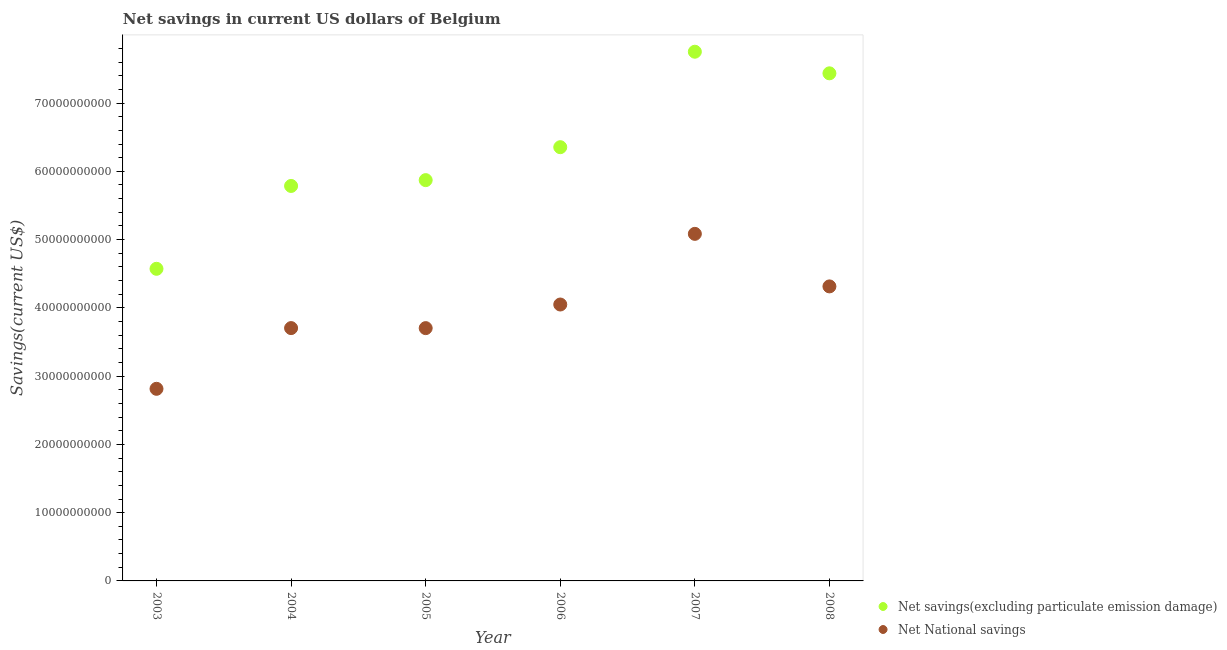What is the net savings(excluding particulate emission damage) in 2007?
Ensure brevity in your answer.  7.75e+1. Across all years, what is the maximum net national savings?
Your answer should be very brief. 5.08e+1. Across all years, what is the minimum net national savings?
Give a very brief answer. 2.81e+1. What is the total net national savings in the graph?
Give a very brief answer. 2.37e+11. What is the difference between the net national savings in 2003 and that in 2008?
Offer a terse response. -1.50e+1. What is the difference between the net savings(excluding particulate emission damage) in 2007 and the net national savings in 2005?
Offer a very short reply. 4.05e+1. What is the average net savings(excluding particulate emission damage) per year?
Provide a succinct answer. 6.30e+1. In the year 2007, what is the difference between the net national savings and net savings(excluding particulate emission damage)?
Ensure brevity in your answer.  -2.67e+1. What is the ratio of the net savings(excluding particulate emission damage) in 2004 to that in 2008?
Offer a terse response. 0.78. Is the net national savings in 2004 less than that in 2008?
Your answer should be compact. Yes. What is the difference between the highest and the second highest net savings(excluding particulate emission damage)?
Your answer should be very brief. 3.16e+09. What is the difference between the highest and the lowest net savings(excluding particulate emission damage)?
Offer a very short reply. 3.18e+1. Does the net national savings monotonically increase over the years?
Offer a terse response. No. Is the net national savings strictly less than the net savings(excluding particulate emission damage) over the years?
Your response must be concise. Yes. How many years are there in the graph?
Provide a short and direct response. 6. What is the difference between two consecutive major ticks on the Y-axis?
Give a very brief answer. 1.00e+1. Are the values on the major ticks of Y-axis written in scientific E-notation?
Provide a short and direct response. No. Does the graph contain any zero values?
Ensure brevity in your answer.  No. Where does the legend appear in the graph?
Offer a very short reply. Bottom right. How many legend labels are there?
Offer a terse response. 2. How are the legend labels stacked?
Provide a short and direct response. Vertical. What is the title of the graph?
Offer a very short reply. Net savings in current US dollars of Belgium. Does "Netherlands" appear as one of the legend labels in the graph?
Provide a succinct answer. No. What is the label or title of the Y-axis?
Your answer should be very brief. Savings(current US$). What is the Savings(current US$) of Net savings(excluding particulate emission damage) in 2003?
Ensure brevity in your answer.  4.57e+1. What is the Savings(current US$) of Net National savings in 2003?
Provide a short and direct response. 2.81e+1. What is the Savings(current US$) of Net savings(excluding particulate emission damage) in 2004?
Ensure brevity in your answer.  5.79e+1. What is the Savings(current US$) in Net National savings in 2004?
Give a very brief answer. 3.70e+1. What is the Savings(current US$) in Net savings(excluding particulate emission damage) in 2005?
Offer a very short reply. 5.87e+1. What is the Savings(current US$) in Net National savings in 2005?
Offer a very short reply. 3.70e+1. What is the Savings(current US$) in Net savings(excluding particulate emission damage) in 2006?
Give a very brief answer. 6.35e+1. What is the Savings(current US$) of Net National savings in 2006?
Your response must be concise. 4.05e+1. What is the Savings(current US$) in Net savings(excluding particulate emission damage) in 2007?
Your answer should be compact. 7.75e+1. What is the Savings(current US$) of Net National savings in 2007?
Provide a succinct answer. 5.08e+1. What is the Savings(current US$) of Net savings(excluding particulate emission damage) in 2008?
Your answer should be compact. 7.44e+1. What is the Savings(current US$) in Net National savings in 2008?
Your answer should be compact. 4.31e+1. Across all years, what is the maximum Savings(current US$) in Net savings(excluding particulate emission damage)?
Keep it short and to the point. 7.75e+1. Across all years, what is the maximum Savings(current US$) in Net National savings?
Provide a short and direct response. 5.08e+1. Across all years, what is the minimum Savings(current US$) in Net savings(excluding particulate emission damage)?
Offer a terse response. 4.57e+1. Across all years, what is the minimum Savings(current US$) of Net National savings?
Make the answer very short. 2.81e+1. What is the total Savings(current US$) in Net savings(excluding particulate emission damage) in the graph?
Your answer should be compact. 3.78e+11. What is the total Savings(current US$) in Net National savings in the graph?
Keep it short and to the point. 2.37e+11. What is the difference between the Savings(current US$) in Net savings(excluding particulate emission damage) in 2003 and that in 2004?
Offer a terse response. -1.21e+1. What is the difference between the Savings(current US$) of Net National savings in 2003 and that in 2004?
Ensure brevity in your answer.  -8.90e+09. What is the difference between the Savings(current US$) in Net savings(excluding particulate emission damage) in 2003 and that in 2005?
Your response must be concise. -1.30e+1. What is the difference between the Savings(current US$) of Net National savings in 2003 and that in 2005?
Keep it short and to the point. -8.89e+09. What is the difference between the Savings(current US$) of Net savings(excluding particulate emission damage) in 2003 and that in 2006?
Ensure brevity in your answer.  -1.78e+1. What is the difference between the Savings(current US$) of Net National savings in 2003 and that in 2006?
Provide a short and direct response. -1.23e+1. What is the difference between the Savings(current US$) of Net savings(excluding particulate emission damage) in 2003 and that in 2007?
Your answer should be compact. -3.18e+1. What is the difference between the Savings(current US$) in Net National savings in 2003 and that in 2007?
Make the answer very short. -2.27e+1. What is the difference between the Savings(current US$) in Net savings(excluding particulate emission damage) in 2003 and that in 2008?
Your answer should be compact. -2.86e+1. What is the difference between the Savings(current US$) of Net National savings in 2003 and that in 2008?
Your response must be concise. -1.50e+1. What is the difference between the Savings(current US$) of Net savings(excluding particulate emission damage) in 2004 and that in 2005?
Your answer should be compact. -8.53e+08. What is the difference between the Savings(current US$) of Net National savings in 2004 and that in 2005?
Your response must be concise. 5.81e+06. What is the difference between the Savings(current US$) of Net savings(excluding particulate emission damage) in 2004 and that in 2006?
Keep it short and to the point. -5.68e+09. What is the difference between the Savings(current US$) in Net National savings in 2004 and that in 2006?
Your response must be concise. -3.45e+09. What is the difference between the Savings(current US$) in Net savings(excluding particulate emission damage) in 2004 and that in 2007?
Offer a very short reply. -1.97e+1. What is the difference between the Savings(current US$) in Net National savings in 2004 and that in 2007?
Provide a succinct answer. -1.38e+1. What is the difference between the Savings(current US$) in Net savings(excluding particulate emission damage) in 2004 and that in 2008?
Offer a very short reply. -1.65e+1. What is the difference between the Savings(current US$) of Net National savings in 2004 and that in 2008?
Give a very brief answer. -6.11e+09. What is the difference between the Savings(current US$) of Net savings(excluding particulate emission damage) in 2005 and that in 2006?
Make the answer very short. -4.83e+09. What is the difference between the Savings(current US$) of Net National savings in 2005 and that in 2006?
Provide a succinct answer. -3.46e+09. What is the difference between the Savings(current US$) in Net savings(excluding particulate emission damage) in 2005 and that in 2007?
Keep it short and to the point. -1.88e+1. What is the difference between the Savings(current US$) of Net National savings in 2005 and that in 2007?
Offer a terse response. -1.38e+1. What is the difference between the Savings(current US$) in Net savings(excluding particulate emission damage) in 2005 and that in 2008?
Provide a short and direct response. -1.56e+1. What is the difference between the Savings(current US$) of Net National savings in 2005 and that in 2008?
Your response must be concise. -6.11e+09. What is the difference between the Savings(current US$) of Net savings(excluding particulate emission damage) in 2006 and that in 2007?
Provide a short and direct response. -1.40e+1. What is the difference between the Savings(current US$) of Net National savings in 2006 and that in 2007?
Provide a short and direct response. -1.04e+1. What is the difference between the Savings(current US$) in Net savings(excluding particulate emission damage) in 2006 and that in 2008?
Provide a succinct answer. -1.08e+1. What is the difference between the Savings(current US$) in Net National savings in 2006 and that in 2008?
Provide a succinct answer. -2.65e+09. What is the difference between the Savings(current US$) in Net savings(excluding particulate emission damage) in 2007 and that in 2008?
Your answer should be compact. 3.16e+09. What is the difference between the Savings(current US$) in Net National savings in 2007 and that in 2008?
Make the answer very short. 7.70e+09. What is the difference between the Savings(current US$) of Net savings(excluding particulate emission damage) in 2003 and the Savings(current US$) of Net National savings in 2004?
Your response must be concise. 8.69e+09. What is the difference between the Savings(current US$) in Net savings(excluding particulate emission damage) in 2003 and the Savings(current US$) in Net National savings in 2005?
Offer a terse response. 8.69e+09. What is the difference between the Savings(current US$) in Net savings(excluding particulate emission damage) in 2003 and the Savings(current US$) in Net National savings in 2006?
Give a very brief answer. 5.23e+09. What is the difference between the Savings(current US$) in Net savings(excluding particulate emission damage) in 2003 and the Savings(current US$) in Net National savings in 2007?
Provide a short and direct response. -5.12e+09. What is the difference between the Savings(current US$) of Net savings(excluding particulate emission damage) in 2003 and the Savings(current US$) of Net National savings in 2008?
Your answer should be compact. 2.58e+09. What is the difference between the Savings(current US$) in Net savings(excluding particulate emission damage) in 2004 and the Savings(current US$) in Net National savings in 2005?
Provide a short and direct response. 2.08e+1. What is the difference between the Savings(current US$) of Net savings(excluding particulate emission damage) in 2004 and the Savings(current US$) of Net National savings in 2006?
Provide a short and direct response. 1.74e+1. What is the difference between the Savings(current US$) in Net savings(excluding particulate emission damage) in 2004 and the Savings(current US$) in Net National savings in 2007?
Your answer should be very brief. 7.02e+09. What is the difference between the Savings(current US$) in Net savings(excluding particulate emission damage) in 2004 and the Savings(current US$) in Net National savings in 2008?
Ensure brevity in your answer.  1.47e+1. What is the difference between the Savings(current US$) in Net savings(excluding particulate emission damage) in 2005 and the Savings(current US$) in Net National savings in 2006?
Ensure brevity in your answer.  1.82e+1. What is the difference between the Savings(current US$) of Net savings(excluding particulate emission damage) in 2005 and the Savings(current US$) of Net National savings in 2007?
Your answer should be very brief. 7.87e+09. What is the difference between the Savings(current US$) of Net savings(excluding particulate emission damage) in 2005 and the Savings(current US$) of Net National savings in 2008?
Make the answer very short. 1.56e+1. What is the difference between the Savings(current US$) in Net savings(excluding particulate emission damage) in 2006 and the Savings(current US$) in Net National savings in 2007?
Ensure brevity in your answer.  1.27e+1. What is the difference between the Savings(current US$) of Net savings(excluding particulate emission damage) in 2006 and the Savings(current US$) of Net National savings in 2008?
Your answer should be very brief. 2.04e+1. What is the difference between the Savings(current US$) of Net savings(excluding particulate emission damage) in 2007 and the Savings(current US$) of Net National savings in 2008?
Your answer should be very brief. 3.44e+1. What is the average Savings(current US$) in Net savings(excluding particulate emission damage) per year?
Ensure brevity in your answer.  6.30e+1. What is the average Savings(current US$) of Net National savings per year?
Your response must be concise. 3.94e+1. In the year 2003, what is the difference between the Savings(current US$) in Net savings(excluding particulate emission damage) and Savings(current US$) in Net National savings?
Provide a short and direct response. 1.76e+1. In the year 2004, what is the difference between the Savings(current US$) of Net savings(excluding particulate emission damage) and Savings(current US$) of Net National savings?
Provide a succinct answer. 2.08e+1. In the year 2005, what is the difference between the Savings(current US$) in Net savings(excluding particulate emission damage) and Savings(current US$) in Net National savings?
Give a very brief answer. 2.17e+1. In the year 2006, what is the difference between the Savings(current US$) in Net savings(excluding particulate emission damage) and Savings(current US$) in Net National savings?
Your answer should be compact. 2.30e+1. In the year 2007, what is the difference between the Savings(current US$) of Net savings(excluding particulate emission damage) and Savings(current US$) of Net National savings?
Keep it short and to the point. 2.67e+1. In the year 2008, what is the difference between the Savings(current US$) in Net savings(excluding particulate emission damage) and Savings(current US$) in Net National savings?
Make the answer very short. 3.12e+1. What is the ratio of the Savings(current US$) in Net savings(excluding particulate emission damage) in 2003 to that in 2004?
Provide a short and direct response. 0.79. What is the ratio of the Savings(current US$) of Net National savings in 2003 to that in 2004?
Offer a terse response. 0.76. What is the ratio of the Savings(current US$) in Net savings(excluding particulate emission damage) in 2003 to that in 2005?
Offer a terse response. 0.78. What is the ratio of the Savings(current US$) in Net National savings in 2003 to that in 2005?
Ensure brevity in your answer.  0.76. What is the ratio of the Savings(current US$) of Net savings(excluding particulate emission damage) in 2003 to that in 2006?
Offer a terse response. 0.72. What is the ratio of the Savings(current US$) of Net National savings in 2003 to that in 2006?
Make the answer very short. 0.69. What is the ratio of the Savings(current US$) in Net savings(excluding particulate emission damage) in 2003 to that in 2007?
Offer a terse response. 0.59. What is the ratio of the Savings(current US$) in Net National savings in 2003 to that in 2007?
Your response must be concise. 0.55. What is the ratio of the Savings(current US$) of Net savings(excluding particulate emission damage) in 2003 to that in 2008?
Provide a short and direct response. 0.61. What is the ratio of the Savings(current US$) in Net National savings in 2003 to that in 2008?
Give a very brief answer. 0.65. What is the ratio of the Savings(current US$) of Net savings(excluding particulate emission damage) in 2004 to that in 2005?
Keep it short and to the point. 0.99. What is the ratio of the Savings(current US$) in Net savings(excluding particulate emission damage) in 2004 to that in 2006?
Provide a succinct answer. 0.91. What is the ratio of the Savings(current US$) in Net National savings in 2004 to that in 2006?
Make the answer very short. 0.91. What is the ratio of the Savings(current US$) in Net savings(excluding particulate emission damage) in 2004 to that in 2007?
Give a very brief answer. 0.75. What is the ratio of the Savings(current US$) of Net National savings in 2004 to that in 2007?
Ensure brevity in your answer.  0.73. What is the ratio of the Savings(current US$) of Net savings(excluding particulate emission damage) in 2004 to that in 2008?
Make the answer very short. 0.78. What is the ratio of the Savings(current US$) of Net National savings in 2004 to that in 2008?
Ensure brevity in your answer.  0.86. What is the ratio of the Savings(current US$) of Net savings(excluding particulate emission damage) in 2005 to that in 2006?
Provide a succinct answer. 0.92. What is the ratio of the Savings(current US$) of Net National savings in 2005 to that in 2006?
Give a very brief answer. 0.91. What is the ratio of the Savings(current US$) in Net savings(excluding particulate emission damage) in 2005 to that in 2007?
Your answer should be very brief. 0.76. What is the ratio of the Savings(current US$) in Net National savings in 2005 to that in 2007?
Provide a succinct answer. 0.73. What is the ratio of the Savings(current US$) of Net savings(excluding particulate emission damage) in 2005 to that in 2008?
Offer a terse response. 0.79. What is the ratio of the Savings(current US$) of Net National savings in 2005 to that in 2008?
Provide a short and direct response. 0.86. What is the ratio of the Savings(current US$) of Net savings(excluding particulate emission damage) in 2006 to that in 2007?
Offer a terse response. 0.82. What is the ratio of the Savings(current US$) of Net National savings in 2006 to that in 2007?
Keep it short and to the point. 0.8. What is the ratio of the Savings(current US$) in Net savings(excluding particulate emission damage) in 2006 to that in 2008?
Ensure brevity in your answer.  0.85. What is the ratio of the Savings(current US$) of Net National savings in 2006 to that in 2008?
Provide a succinct answer. 0.94. What is the ratio of the Savings(current US$) in Net savings(excluding particulate emission damage) in 2007 to that in 2008?
Offer a very short reply. 1.04. What is the ratio of the Savings(current US$) of Net National savings in 2007 to that in 2008?
Provide a short and direct response. 1.18. What is the difference between the highest and the second highest Savings(current US$) in Net savings(excluding particulate emission damage)?
Provide a short and direct response. 3.16e+09. What is the difference between the highest and the second highest Savings(current US$) in Net National savings?
Give a very brief answer. 7.70e+09. What is the difference between the highest and the lowest Savings(current US$) of Net savings(excluding particulate emission damage)?
Provide a short and direct response. 3.18e+1. What is the difference between the highest and the lowest Savings(current US$) of Net National savings?
Keep it short and to the point. 2.27e+1. 